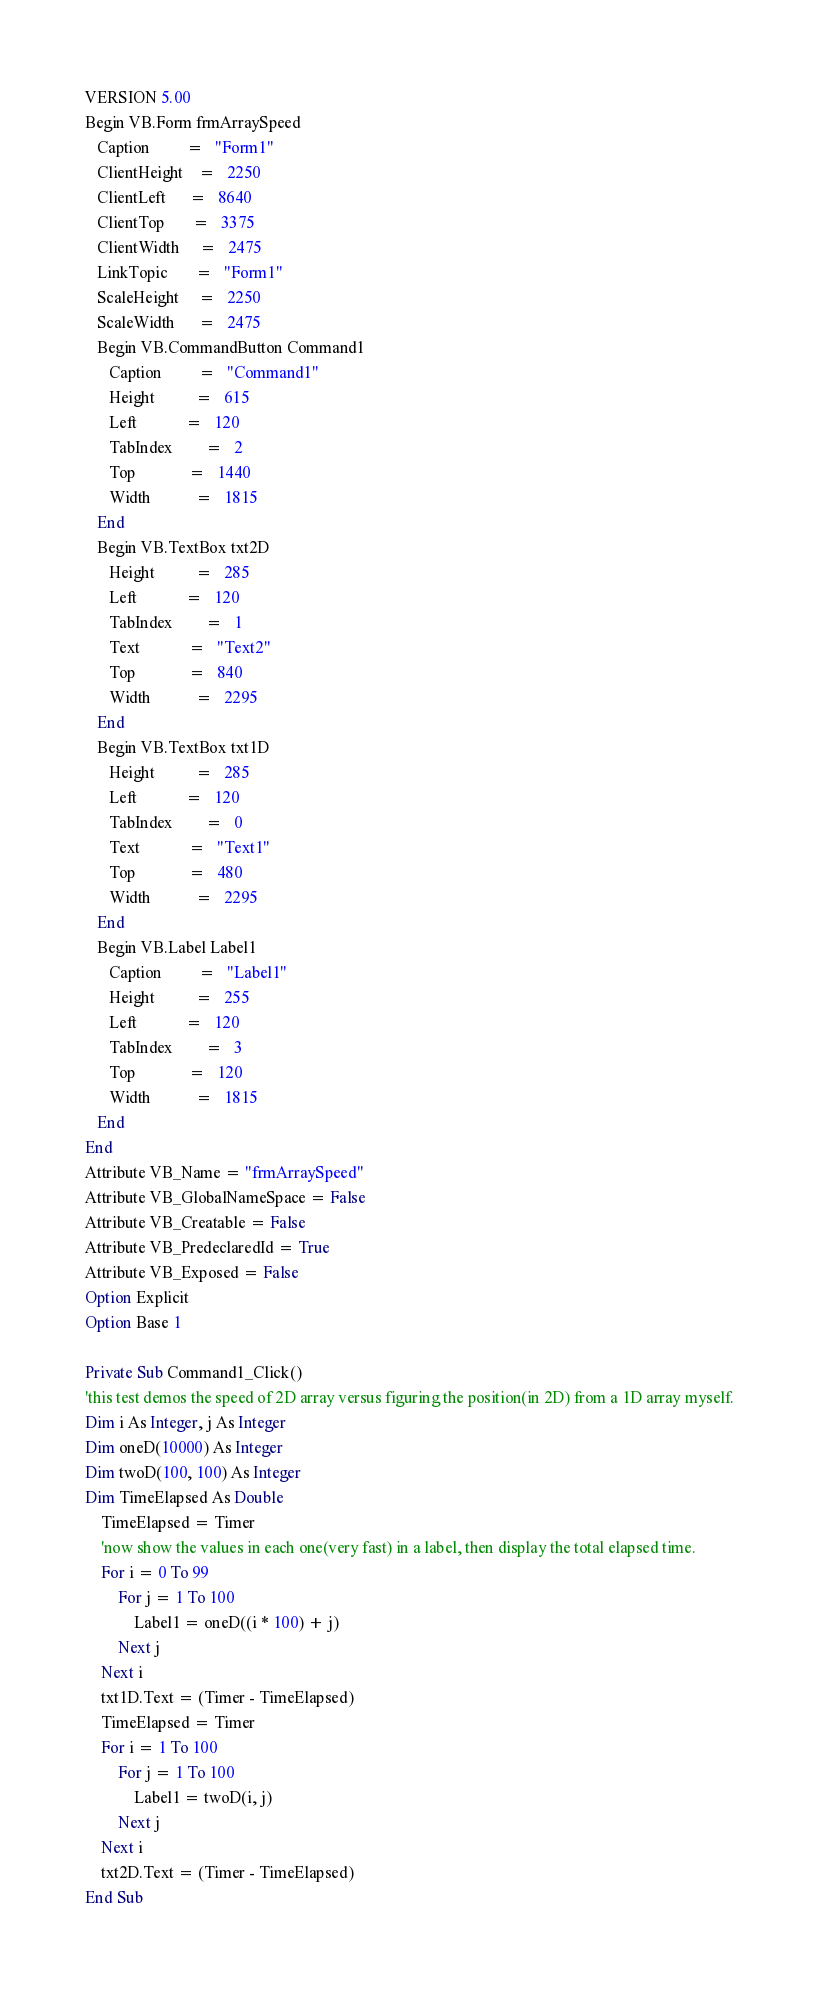<code> <loc_0><loc_0><loc_500><loc_500><_VisualBasic_>VERSION 5.00
Begin VB.Form frmArraySpeed 
   Caption         =   "Form1"
   ClientHeight    =   2250
   ClientLeft      =   8640
   ClientTop       =   3375
   ClientWidth     =   2475
   LinkTopic       =   "Form1"
   ScaleHeight     =   2250
   ScaleWidth      =   2475
   Begin VB.CommandButton Command1 
      Caption         =   "Command1"
      Height          =   615
      Left            =   120
      TabIndex        =   2
      Top             =   1440
      Width           =   1815
   End
   Begin VB.TextBox txt2D 
      Height          =   285
      Left            =   120
      TabIndex        =   1
      Text            =   "Text2"
      Top             =   840
      Width           =   2295
   End
   Begin VB.TextBox txt1D 
      Height          =   285
      Left            =   120
      TabIndex        =   0
      Text            =   "Text1"
      Top             =   480
      Width           =   2295
   End
   Begin VB.Label Label1 
      Caption         =   "Label1"
      Height          =   255
      Left            =   120
      TabIndex        =   3
      Top             =   120
      Width           =   1815
   End
End
Attribute VB_Name = "frmArraySpeed"
Attribute VB_GlobalNameSpace = False
Attribute VB_Creatable = False
Attribute VB_PredeclaredId = True
Attribute VB_Exposed = False
Option Explicit
Option Base 1

Private Sub Command1_Click()
'this test demos the speed of 2D array versus figuring the position(in 2D) from a 1D array myself.
Dim i As Integer, j As Integer
Dim oneD(10000) As Integer
Dim twoD(100, 100) As Integer
Dim TimeElapsed As Double
    TimeElapsed = Timer
    'now show the values in each one(very fast) in a label, then display the total elapsed time.
    For i = 0 To 99
        For j = 1 To 100
            Label1 = oneD((i * 100) + j)
        Next j
    Next i
    txt1D.Text = (Timer - TimeElapsed)
    TimeElapsed = Timer
    For i = 1 To 100
        For j = 1 To 100
            Label1 = twoD(i, j)
        Next j
    Next i
    txt2D.Text = (Timer - TimeElapsed)
End Sub
</code> 